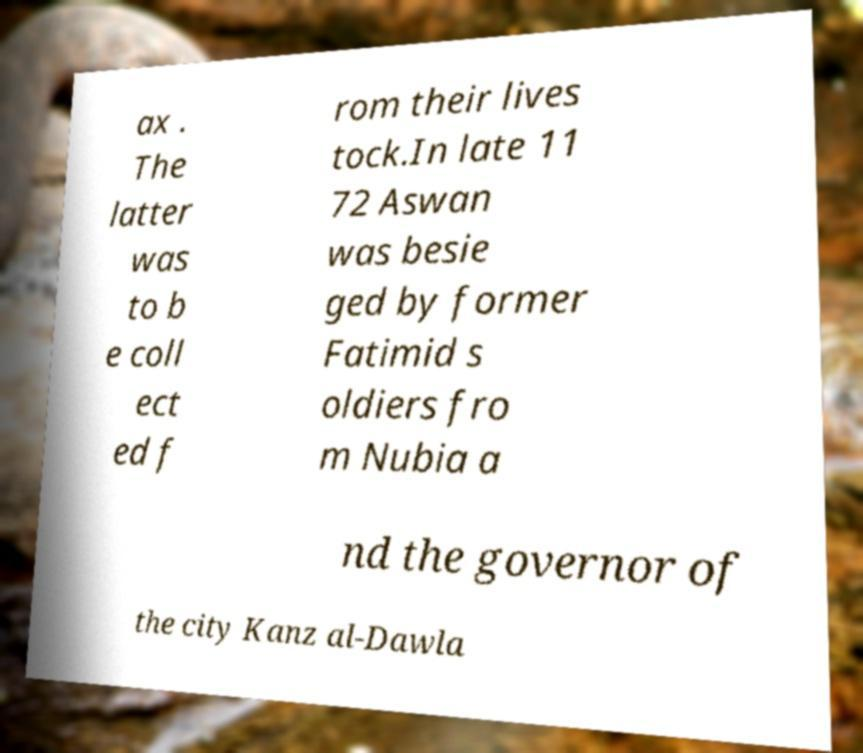Please read and relay the text visible in this image. What does it say? ax . The latter was to b e coll ect ed f rom their lives tock.In late 11 72 Aswan was besie ged by former Fatimid s oldiers fro m Nubia a nd the governor of the city Kanz al-Dawla 